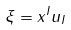<formula> <loc_0><loc_0><loc_500><loc_500>\xi = x ^ { I } { u } _ { I }</formula> 